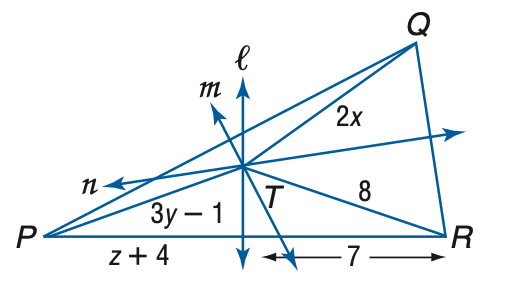Answer the mathemtical geometry problem and directly provide the correct option letter.
Question: Lines l, m, and n are perpendicular bisectors of \triangle P Q R and meet at T. If T Q = 2 x, P T = 3 y - 1, and T R = 8, find y.
Choices: A: 3 B: 4 C: 5 D: 6 A 